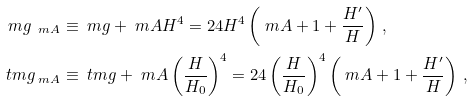<formula> <loc_0><loc_0><loc_500><loc_500>\ m g _ { \ m A } & \equiv \ m g + \ m A H ^ { 4 } = 2 4 H ^ { 4 } \left ( \ m A + 1 + \frac { H ^ { \prime } } { H } \right ) \, , \\ \ t m g _ { \ m A } & \equiv \ t m g + \ m A \left ( \frac { H } { H _ { 0 } } \right ) ^ { 4 } = 2 4 \left ( \frac { H } { H _ { 0 } } \right ) ^ { 4 } \left ( \ m A + 1 + \frac { H ^ { \prime } } { H } \right ) \, ,</formula> 